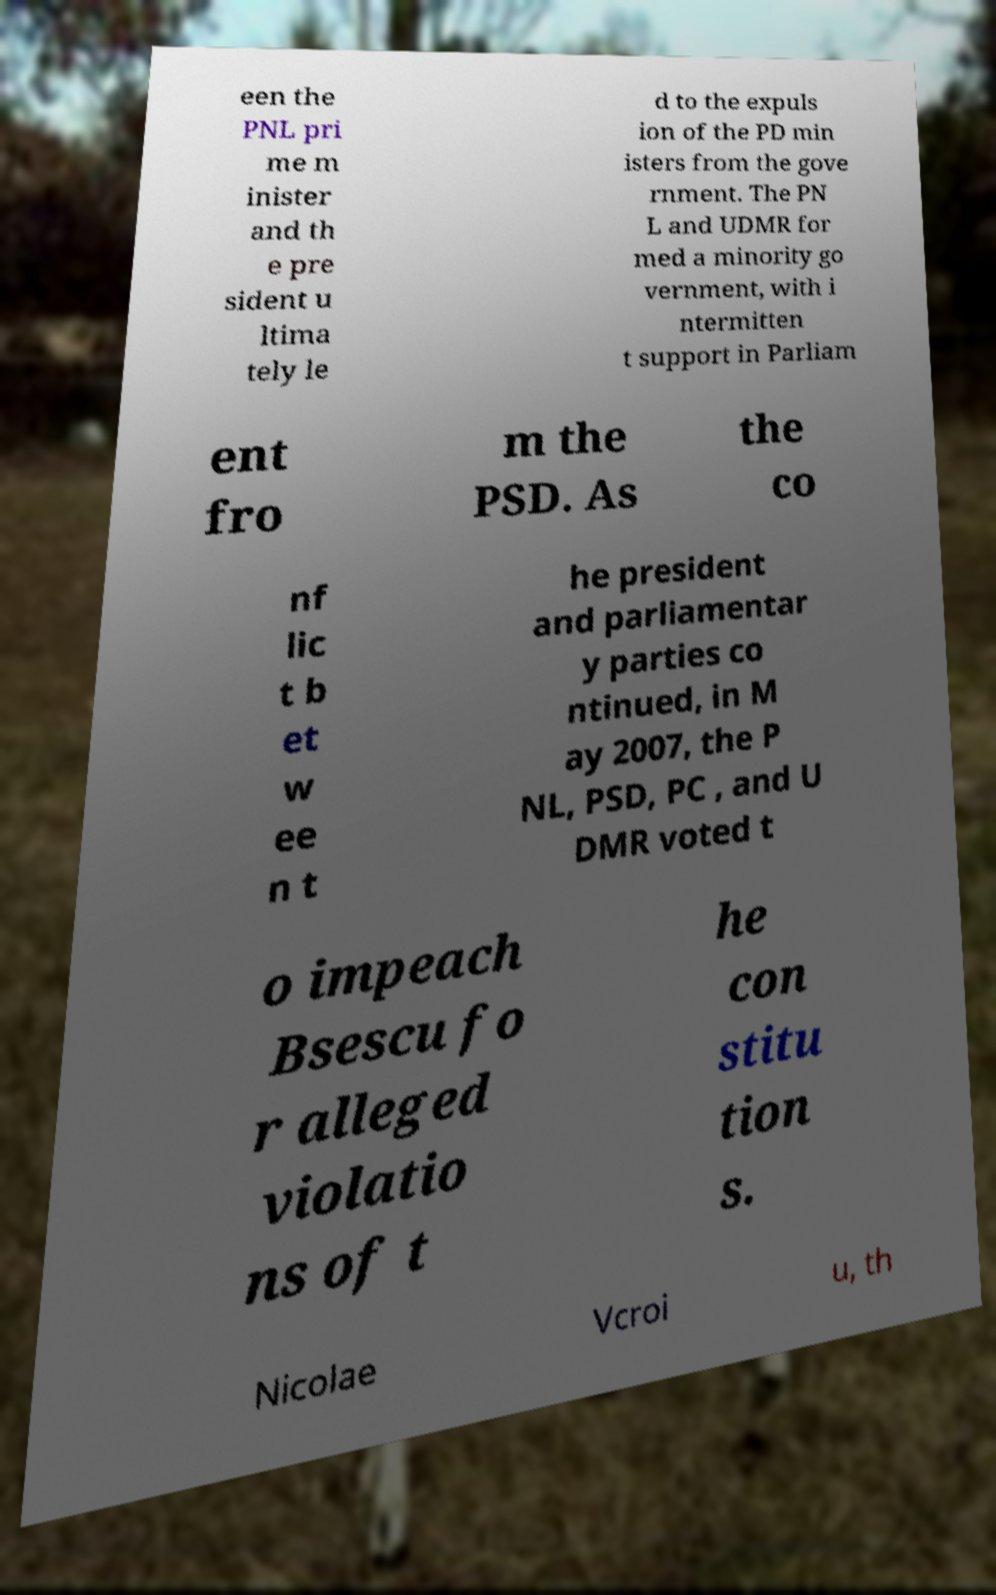What messages or text are displayed in this image? I need them in a readable, typed format. een the PNL pri me m inister and th e pre sident u ltima tely le d to the expuls ion of the PD min isters from the gove rnment. The PN L and UDMR for med a minority go vernment, with i ntermitten t support in Parliam ent fro m the PSD. As the co nf lic t b et w ee n t he president and parliamentar y parties co ntinued, in M ay 2007, the P NL, PSD, PC , and U DMR voted t o impeach Bsescu fo r alleged violatio ns of t he con stitu tion s. Nicolae Vcroi u, th 